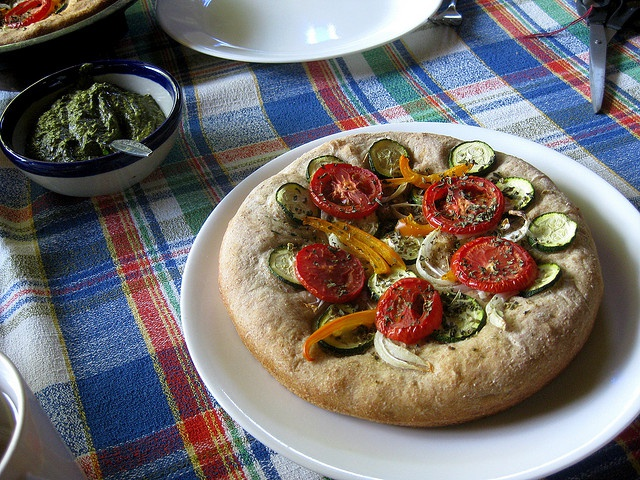Describe the objects in this image and their specific colors. I can see dining table in black, lightgray, darkgray, gray, and maroon tones, pizza in black, maroon, tan, and olive tones, bowl in black, gray, darkgreen, and navy tones, cup in black, gray, and white tones, and scissors in black, gray, and darkgray tones in this image. 